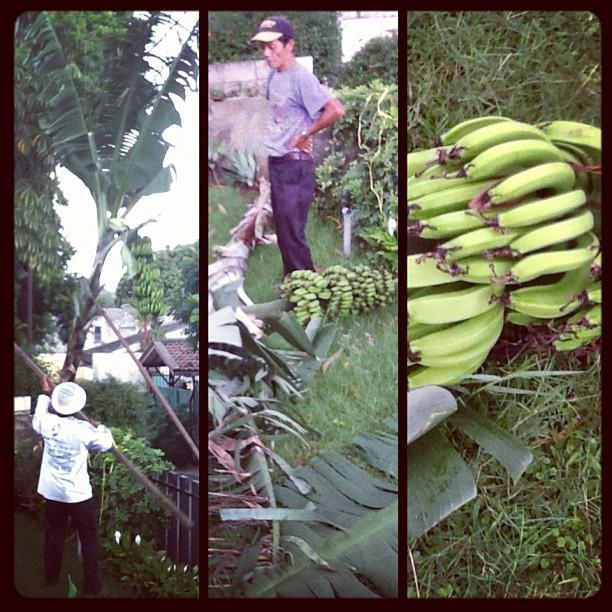How many pic panels are there?
Give a very brief answer. 3. How many bananas can be seen?
Give a very brief answer. 3. How many people are in the picture?
Give a very brief answer. 2. How many bears are there?
Give a very brief answer. 0. 